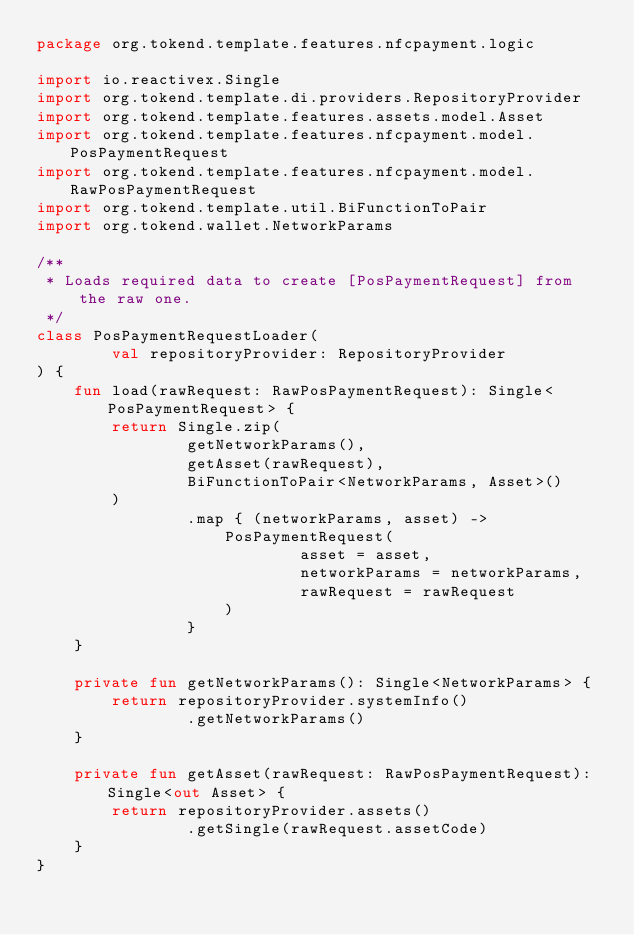Convert code to text. <code><loc_0><loc_0><loc_500><loc_500><_Kotlin_>package org.tokend.template.features.nfcpayment.logic

import io.reactivex.Single
import org.tokend.template.di.providers.RepositoryProvider
import org.tokend.template.features.assets.model.Asset
import org.tokend.template.features.nfcpayment.model.PosPaymentRequest
import org.tokend.template.features.nfcpayment.model.RawPosPaymentRequest
import org.tokend.template.util.BiFunctionToPair
import org.tokend.wallet.NetworkParams

/**
 * Loads required data to create [PosPaymentRequest] from the raw one.
 */
class PosPaymentRequestLoader(
        val repositoryProvider: RepositoryProvider
) {
    fun load(rawRequest: RawPosPaymentRequest): Single<PosPaymentRequest> {
        return Single.zip(
                getNetworkParams(),
                getAsset(rawRequest),
                BiFunctionToPair<NetworkParams, Asset>()
        )
                .map { (networkParams, asset) ->
                    PosPaymentRequest(
                            asset = asset,
                            networkParams = networkParams,
                            rawRequest = rawRequest
                    )
                }
    }

    private fun getNetworkParams(): Single<NetworkParams> {
        return repositoryProvider.systemInfo()
                .getNetworkParams()
    }

    private fun getAsset(rawRequest: RawPosPaymentRequest): Single<out Asset> {
        return repositoryProvider.assets()
                .getSingle(rawRequest.assetCode)
    }
}</code> 